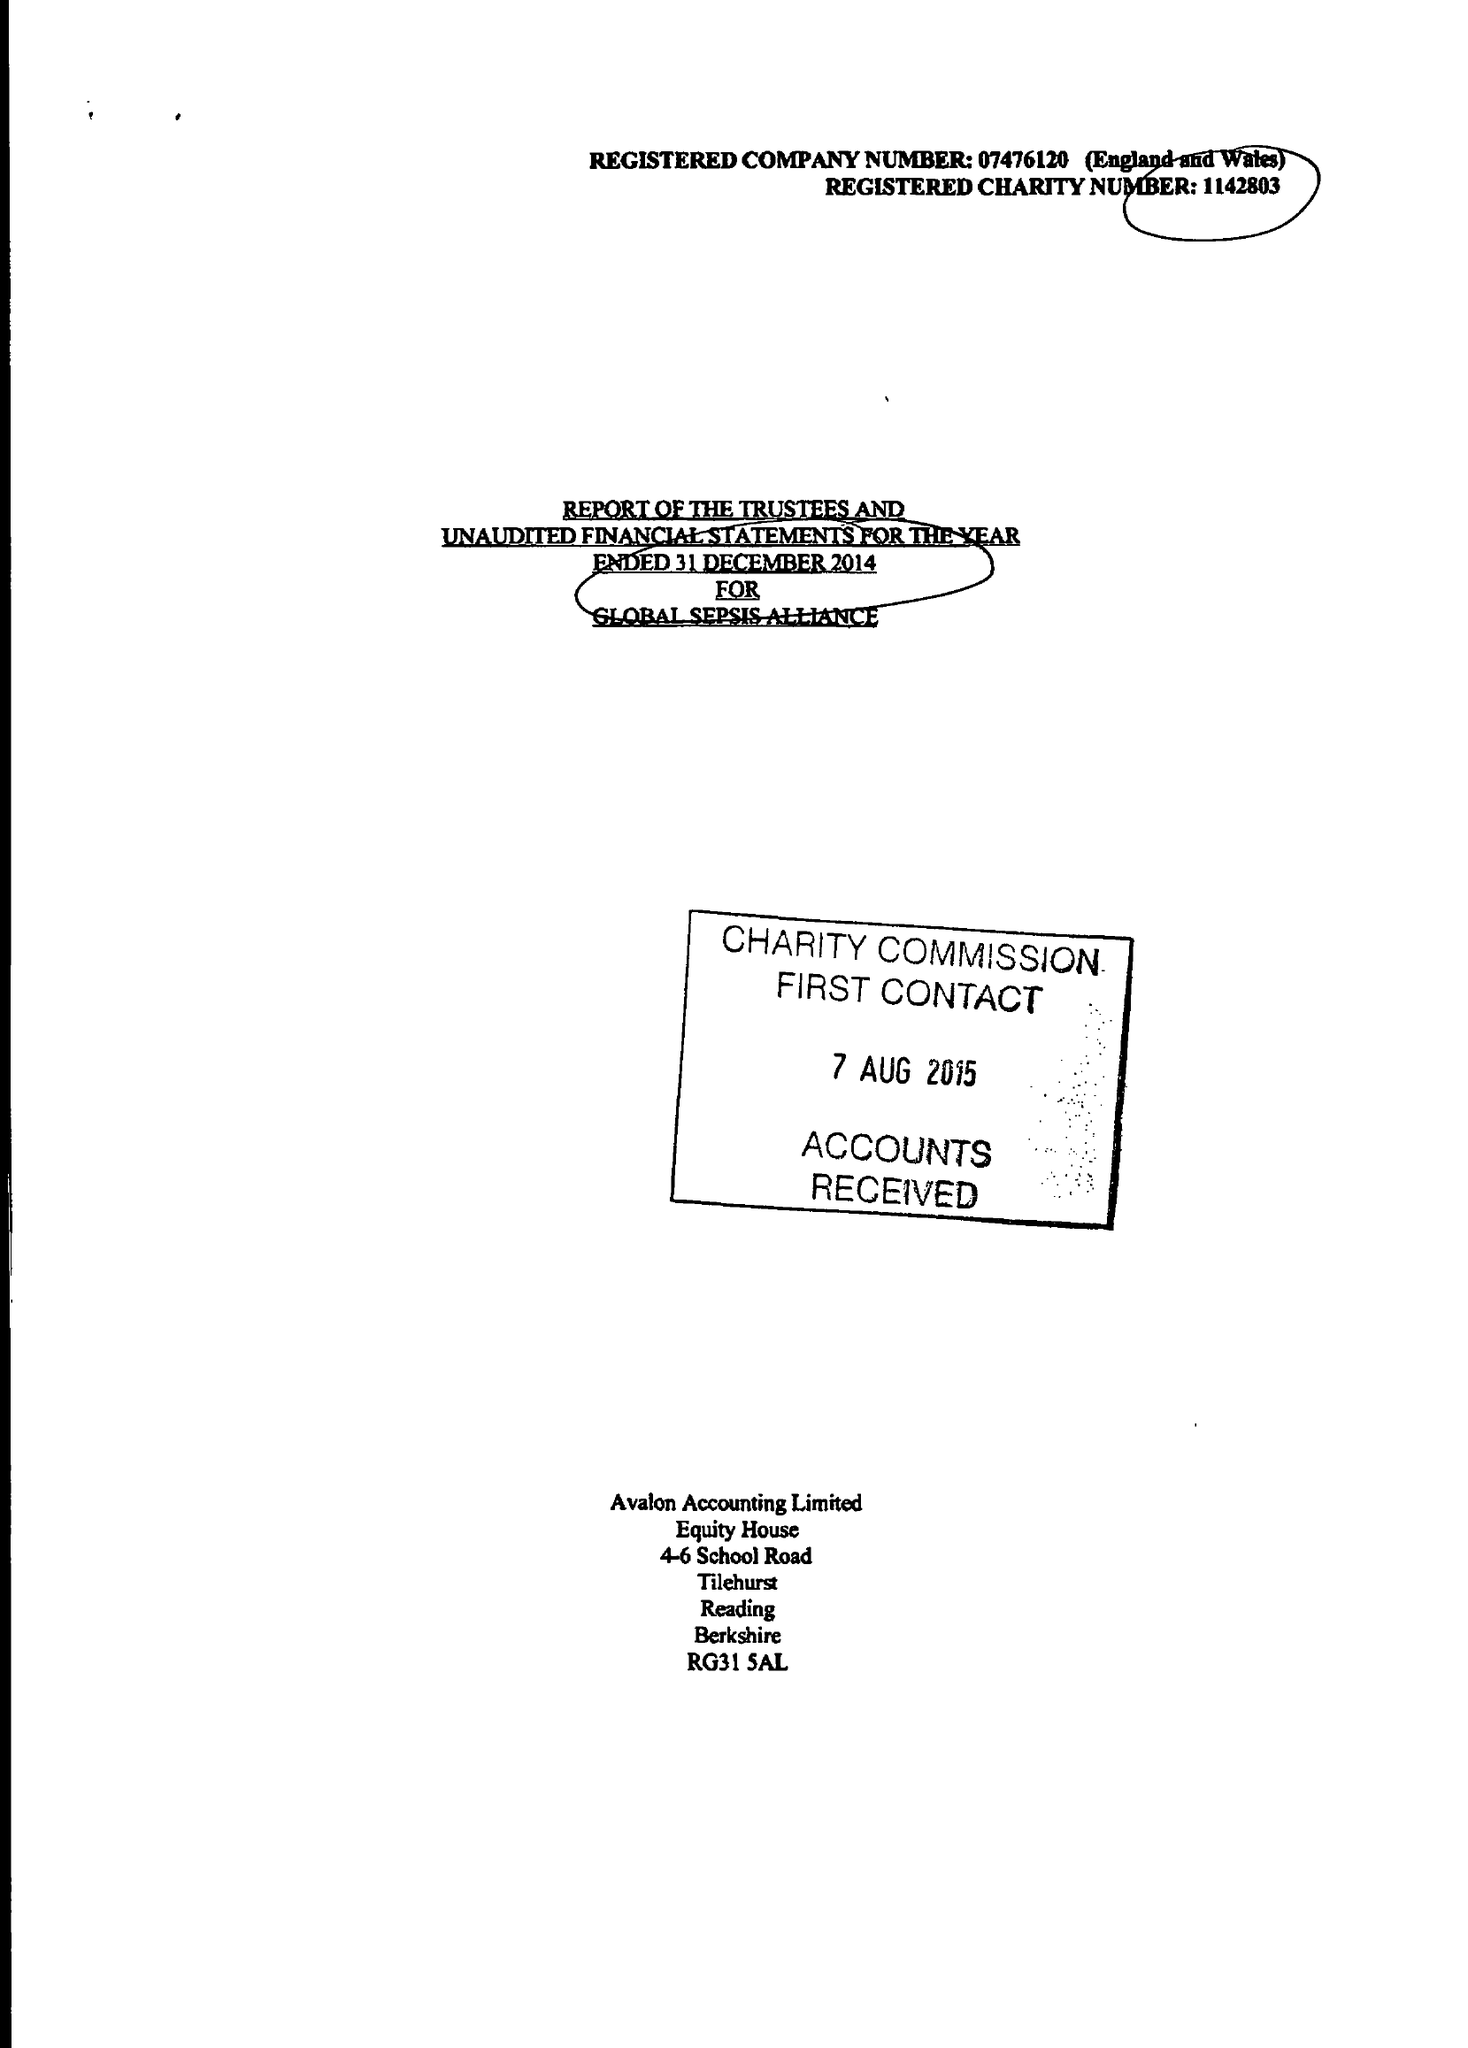What is the value for the income_annually_in_british_pounds?
Answer the question using a single word or phrase. 114074.00 